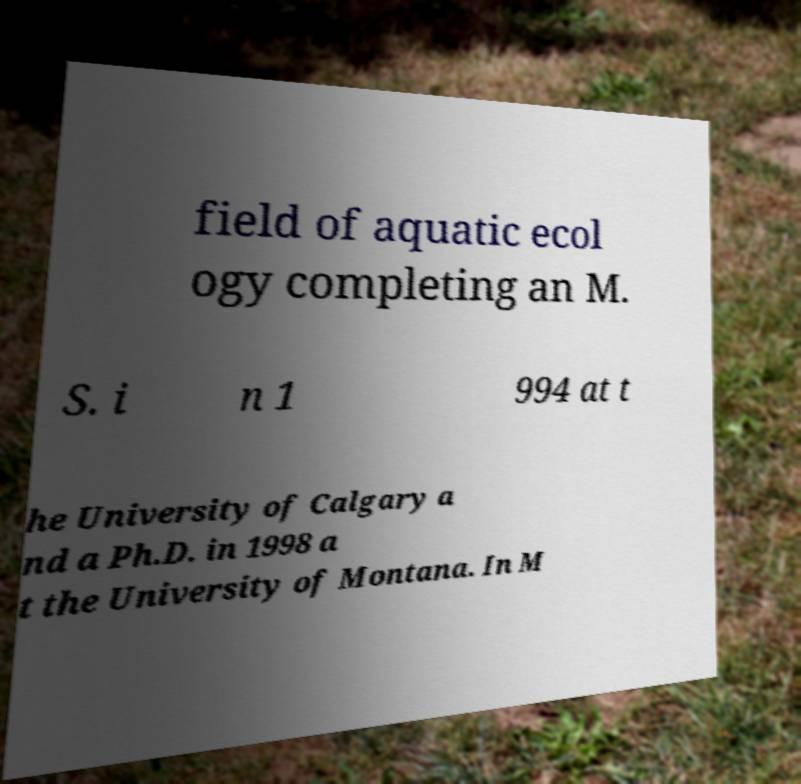For documentation purposes, I need the text within this image transcribed. Could you provide that? field of aquatic ecol ogy completing an M. S. i n 1 994 at t he University of Calgary a nd a Ph.D. in 1998 a t the University of Montana. In M 